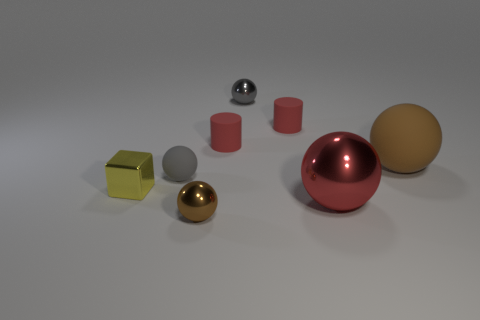How many objects are there, and can you describe their colors? There are seven objects, including a red sphere, a golden sphere, a silver sphere, a dark grey sphere, a light grey cylinder, a yellow metallic cube, and a pinkish-red hemisphere. Which object stands out the most to you? The golden sphere stands out due to its shiny surface and eye-catching color, drawing the viewer's attention amid the other objects. 